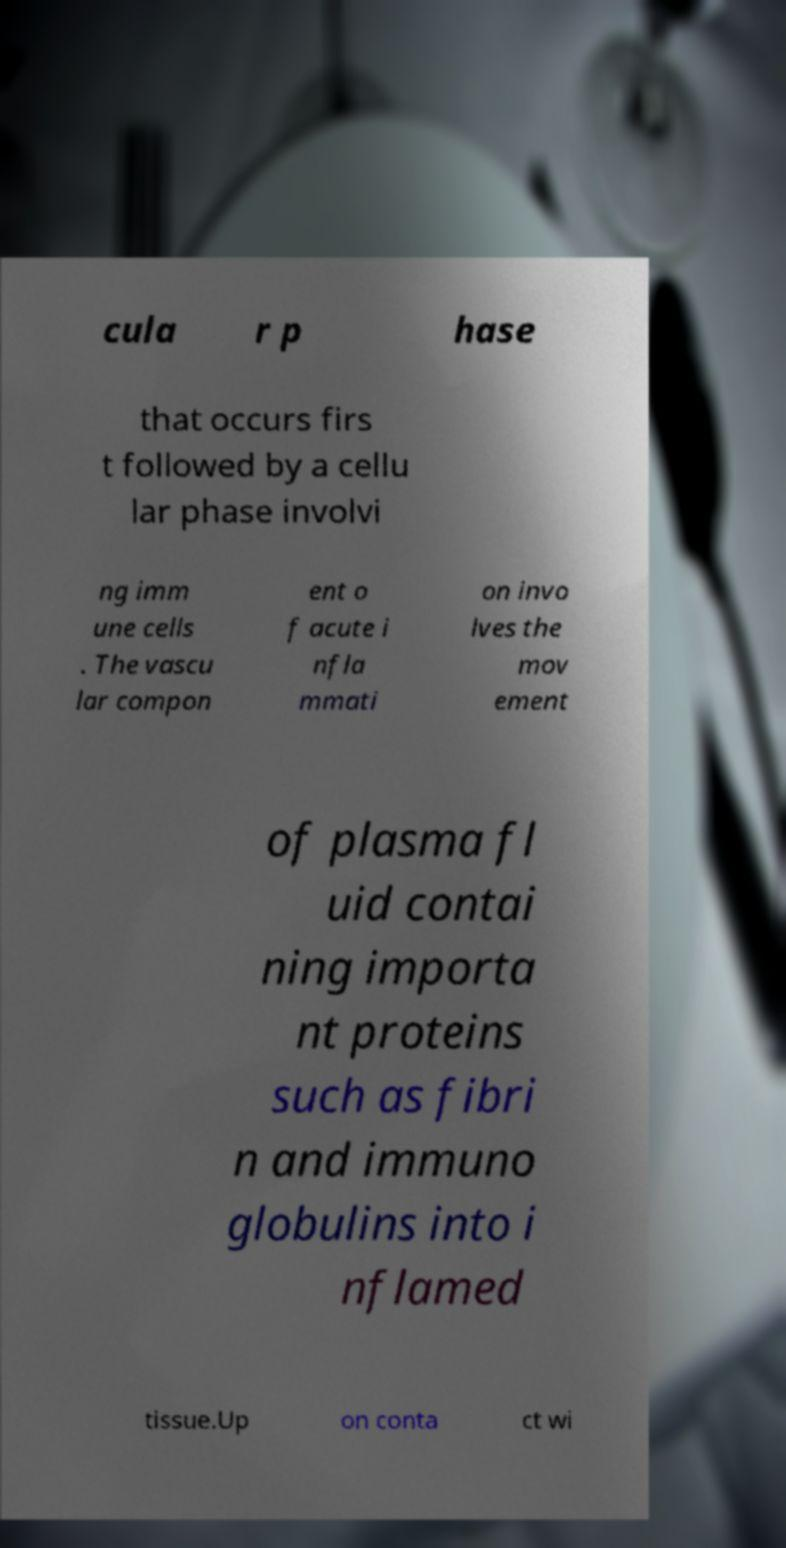Could you assist in decoding the text presented in this image and type it out clearly? cula r p hase that occurs firs t followed by a cellu lar phase involvi ng imm une cells . The vascu lar compon ent o f acute i nfla mmati on invo lves the mov ement of plasma fl uid contai ning importa nt proteins such as fibri n and immuno globulins into i nflamed tissue.Up on conta ct wi 